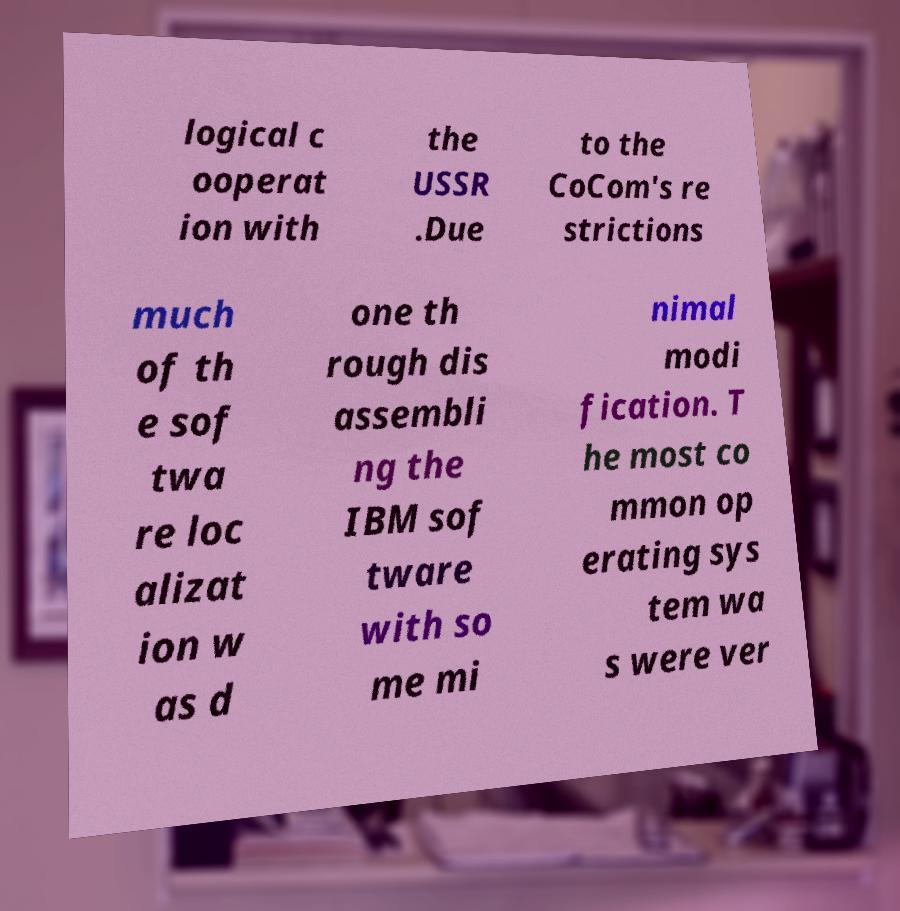For documentation purposes, I need the text within this image transcribed. Could you provide that? logical c ooperat ion with the USSR .Due to the CoCom's re strictions much of th e sof twa re loc alizat ion w as d one th rough dis assembli ng the IBM sof tware with so me mi nimal modi fication. T he most co mmon op erating sys tem wa s were ver 